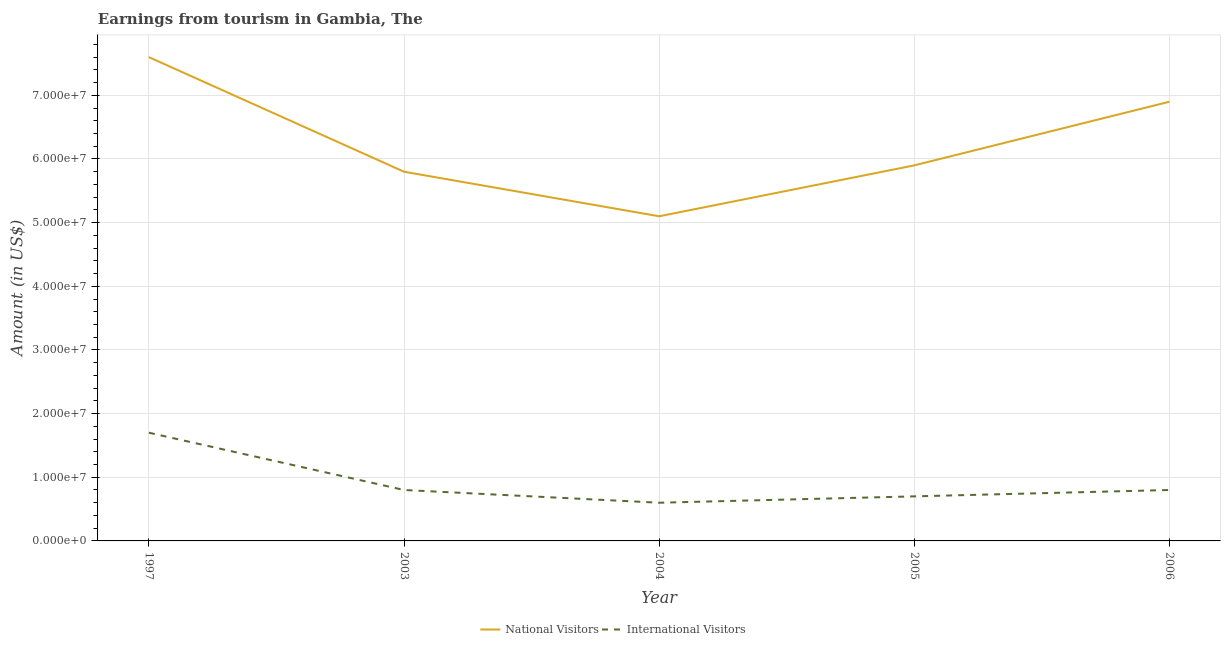Does the line corresponding to amount earned from international visitors intersect with the line corresponding to amount earned from national visitors?
Your answer should be compact. No. What is the amount earned from national visitors in 1997?
Give a very brief answer. 7.60e+07. Across all years, what is the maximum amount earned from international visitors?
Provide a short and direct response. 1.70e+07. Across all years, what is the minimum amount earned from international visitors?
Ensure brevity in your answer.  6.00e+06. What is the total amount earned from international visitors in the graph?
Your answer should be very brief. 4.60e+07. What is the difference between the amount earned from international visitors in 2005 and that in 2006?
Your answer should be very brief. -1.00e+06. What is the difference between the amount earned from international visitors in 2003 and the amount earned from national visitors in 2004?
Give a very brief answer. -4.30e+07. What is the average amount earned from national visitors per year?
Provide a succinct answer. 6.26e+07. In the year 2005, what is the difference between the amount earned from international visitors and amount earned from national visitors?
Make the answer very short. -5.20e+07. In how many years, is the amount earned from international visitors greater than 32000000 US$?
Ensure brevity in your answer.  0. What is the ratio of the amount earned from international visitors in 1997 to that in 2003?
Keep it short and to the point. 2.12. Is the amount earned from international visitors in 1997 less than that in 2003?
Make the answer very short. No. Is the difference between the amount earned from national visitors in 2005 and 2006 greater than the difference between the amount earned from international visitors in 2005 and 2006?
Keep it short and to the point. No. What is the difference between the highest and the second highest amount earned from international visitors?
Give a very brief answer. 9.00e+06. What is the difference between the highest and the lowest amount earned from international visitors?
Offer a very short reply. 1.10e+07. In how many years, is the amount earned from national visitors greater than the average amount earned from national visitors taken over all years?
Ensure brevity in your answer.  2. Is the sum of the amount earned from international visitors in 1997 and 2005 greater than the maximum amount earned from national visitors across all years?
Offer a terse response. No. Does the amount earned from national visitors monotonically increase over the years?
Your answer should be compact. No. Is the amount earned from national visitors strictly greater than the amount earned from international visitors over the years?
Keep it short and to the point. Yes. Is the amount earned from international visitors strictly less than the amount earned from national visitors over the years?
Offer a very short reply. Yes. How many lines are there?
Provide a succinct answer. 2. Are the values on the major ticks of Y-axis written in scientific E-notation?
Your answer should be compact. Yes. What is the title of the graph?
Provide a short and direct response. Earnings from tourism in Gambia, The. Does "Male" appear as one of the legend labels in the graph?
Make the answer very short. No. What is the Amount (in US$) in National Visitors in 1997?
Your answer should be compact. 7.60e+07. What is the Amount (in US$) of International Visitors in 1997?
Keep it short and to the point. 1.70e+07. What is the Amount (in US$) of National Visitors in 2003?
Offer a terse response. 5.80e+07. What is the Amount (in US$) of National Visitors in 2004?
Your response must be concise. 5.10e+07. What is the Amount (in US$) of National Visitors in 2005?
Offer a very short reply. 5.90e+07. What is the Amount (in US$) in International Visitors in 2005?
Offer a very short reply. 7.00e+06. What is the Amount (in US$) of National Visitors in 2006?
Your answer should be compact. 6.90e+07. Across all years, what is the maximum Amount (in US$) in National Visitors?
Your response must be concise. 7.60e+07. Across all years, what is the maximum Amount (in US$) of International Visitors?
Keep it short and to the point. 1.70e+07. Across all years, what is the minimum Amount (in US$) in National Visitors?
Provide a short and direct response. 5.10e+07. Across all years, what is the minimum Amount (in US$) of International Visitors?
Provide a short and direct response. 6.00e+06. What is the total Amount (in US$) of National Visitors in the graph?
Make the answer very short. 3.13e+08. What is the total Amount (in US$) of International Visitors in the graph?
Give a very brief answer. 4.60e+07. What is the difference between the Amount (in US$) in National Visitors in 1997 and that in 2003?
Keep it short and to the point. 1.80e+07. What is the difference between the Amount (in US$) in International Visitors in 1997 and that in 2003?
Provide a succinct answer. 9.00e+06. What is the difference between the Amount (in US$) in National Visitors in 1997 and that in 2004?
Make the answer very short. 2.50e+07. What is the difference between the Amount (in US$) in International Visitors in 1997 and that in 2004?
Keep it short and to the point. 1.10e+07. What is the difference between the Amount (in US$) in National Visitors in 1997 and that in 2005?
Offer a very short reply. 1.70e+07. What is the difference between the Amount (in US$) of National Visitors in 1997 and that in 2006?
Keep it short and to the point. 7.00e+06. What is the difference between the Amount (in US$) in International Visitors in 1997 and that in 2006?
Give a very brief answer. 9.00e+06. What is the difference between the Amount (in US$) of National Visitors in 2003 and that in 2004?
Keep it short and to the point. 7.00e+06. What is the difference between the Amount (in US$) in International Visitors in 2003 and that in 2004?
Your answer should be compact. 2.00e+06. What is the difference between the Amount (in US$) of National Visitors in 2003 and that in 2006?
Provide a short and direct response. -1.10e+07. What is the difference between the Amount (in US$) of International Visitors in 2003 and that in 2006?
Your answer should be very brief. 0. What is the difference between the Amount (in US$) in National Visitors in 2004 and that in 2005?
Give a very brief answer. -8.00e+06. What is the difference between the Amount (in US$) of International Visitors in 2004 and that in 2005?
Your answer should be compact. -1.00e+06. What is the difference between the Amount (in US$) in National Visitors in 2004 and that in 2006?
Ensure brevity in your answer.  -1.80e+07. What is the difference between the Amount (in US$) of International Visitors in 2004 and that in 2006?
Keep it short and to the point. -2.00e+06. What is the difference between the Amount (in US$) of National Visitors in 2005 and that in 2006?
Your response must be concise. -1.00e+07. What is the difference between the Amount (in US$) in International Visitors in 2005 and that in 2006?
Your response must be concise. -1.00e+06. What is the difference between the Amount (in US$) in National Visitors in 1997 and the Amount (in US$) in International Visitors in 2003?
Keep it short and to the point. 6.80e+07. What is the difference between the Amount (in US$) in National Visitors in 1997 and the Amount (in US$) in International Visitors in 2004?
Your answer should be compact. 7.00e+07. What is the difference between the Amount (in US$) in National Visitors in 1997 and the Amount (in US$) in International Visitors in 2005?
Keep it short and to the point. 6.90e+07. What is the difference between the Amount (in US$) of National Visitors in 1997 and the Amount (in US$) of International Visitors in 2006?
Your answer should be very brief. 6.80e+07. What is the difference between the Amount (in US$) in National Visitors in 2003 and the Amount (in US$) in International Visitors in 2004?
Your response must be concise. 5.20e+07. What is the difference between the Amount (in US$) of National Visitors in 2003 and the Amount (in US$) of International Visitors in 2005?
Keep it short and to the point. 5.10e+07. What is the difference between the Amount (in US$) of National Visitors in 2003 and the Amount (in US$) of International Visitors in 2006?
Provide a short and direct response. 5.00e+07. What is the difference between the Amount (in US$) in National Visitors in 2004 and the Amount (in US$) in International Visitors in 2005?
Keep it short and to the point. 4.40e+07. What is the difference between the Amount (in US$) in National Visitors in 2004 and the Amount (in US$) in International Visitors in 2006?
Your response must be concise. 4.30e+07. What is the difference between the Amount (in US$) of National Visitors in 2005 and the Amount (in US$) of International Visitors in 2006?
Keep it short and to the point. 5.10e+07. What is the average Amount (in US$) of National Visitors per year?
Give a very brief answer. 6.26e+07. What is the average Amount (in US$) in International Visitors per year?
Give a very brief answer. 9.20e+06. In the year 1997, what is the difference between the Amount (in US$) in National Visitors and Amount (in US$) in International Visitors?
Your answer should be compact. 5.90e+07. In the year 2004, what is the difference between the Amount (in US$) of National Visitors and Amount (in US$) of International Visitors?
Offer a very short reply. 4.50e+07. In the year 2005, what is the difference between the Amount (in US$) of National Visitors and Amount (in US$) of International Visitors?
Keep it short and to the point. 5.20e+07. In the year 2006, what is the difference between the Amount (in US$) in National Visitors and Amount (in US$) in International Visitors?
Your answer should be compact. 6.10e+07. What is the ratio of the Amount (in US$) in National Visitors in 1997 to that in 2003?
Offer a terse response. 1.31. What is the ratio of the Amount (in US$) in International Visitors in 1997 to that in 2003?
Offer a very short reply. 2.12. What is the ratio of the Amount (in US$) of National Visitors in 1997 to that in 2004?
Your answer should be compact. 1.49. What is the ratio of the Amount (in US$) in International Visitors in 1997 to that in 2004?
Your response must be concise. 2.83. What is the ratio of the Amount (in US$) of National Visitors in 1997 to that in 2005?
Make the answer very short. 1.29. What is the ratio of the Amount (in US$) in International Visitors in 1997 to that in 2005?
Provide a succinct answer. 2.43. What is the ratio of the Amount (in US$) of National Visitors in 1997 to that in 2006?
Offer a very short reply. 1.1. What is the ratio of the Amount (in US$) in International Visitors in 1997 to that in 2006?
Your answer should be very brief. 2.12. What is the ratio of the Amount (in US$) of National Visitors in 2003 to that in 2004?
Ensure brevity in your answer.  1.14. What is the ratio of the Amount (in US$) in National Visitors in 2003 to that in 2005?
Your response must be concise. 0.98. What is the ratio of the Amount (in US$) of International Visitors in 2003 to that in 2005?
Make the answer very short. 1.14. What is the ratio of the Amount (in US$) of National Visitors in 2003 to that in 2006?
Provide a short and direct response. 0.84. What is the ratio of the Amount (in US$) of National Visitors in 2004 to that in 2005?
Make the answer very short. 0.86. What is the ratio of the Amount (in US$) of National Visitors in 2004 to that in 2006?
Provide a short and direct response. 0.74. What is the ratio of the Amount (in US$) of National Visitors in 2005 to that in 2006?
Your response must be concise. 0.86. What is the difference between the highest and the second highest Amount (in US$) in National Visitors?
Provide a short and direct response. 7.00e+06. What is the difference between the highest and the second highest Amount (in US$) in International Visitors?
Your response must be concise. 9.00e+06. What is the difference between the highest and the lowest Amount (in US$) of National Visitors?
Keep it short and to the point. 2.50e+07. What is the difference between the highest and the lowest Amount (in US$) in International Visitors?
Offer a terse response. 1.10e+07. 